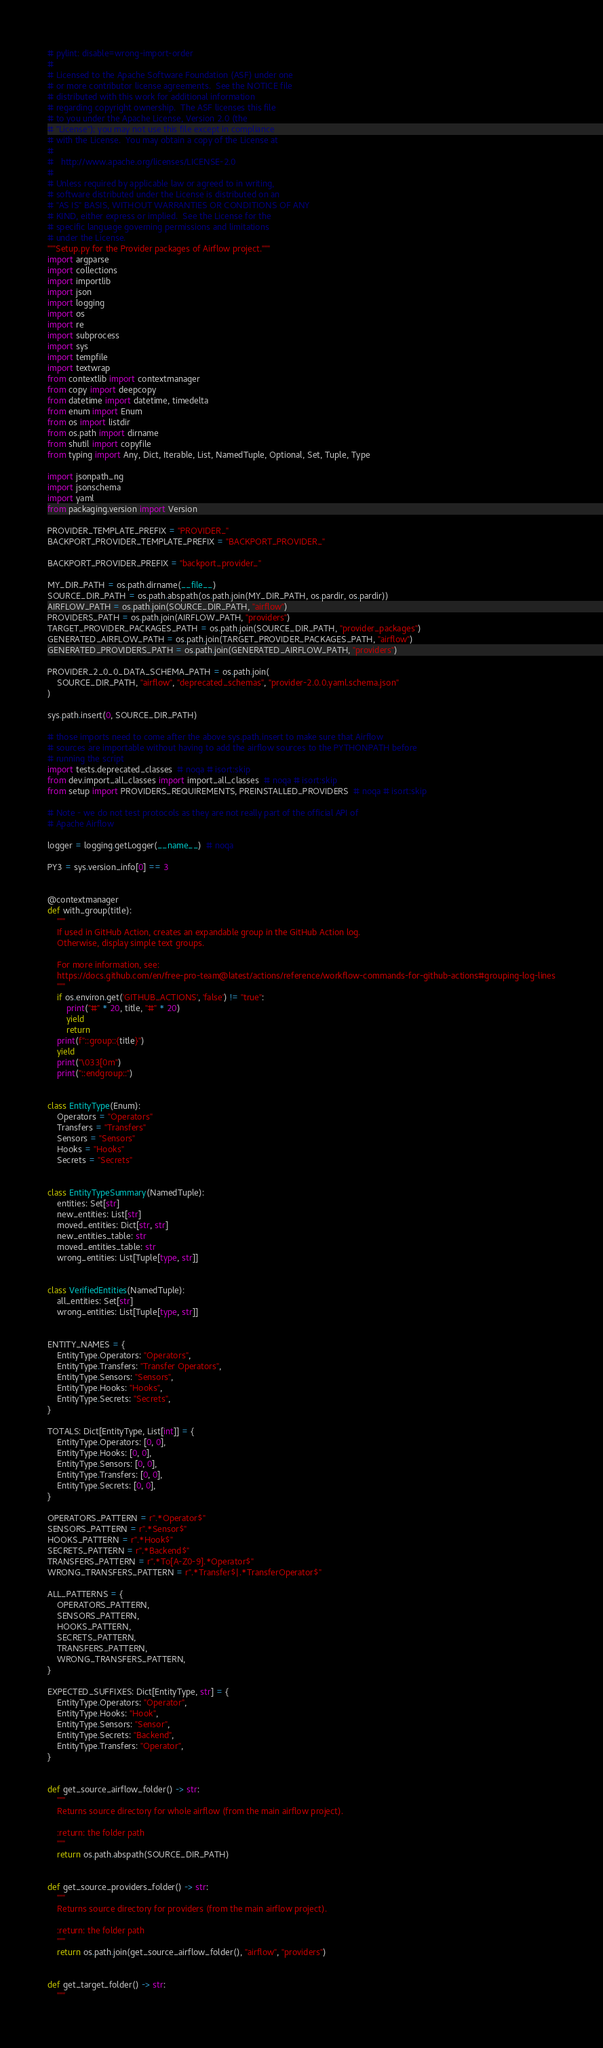<code> <loc_0><loc_0><loc_500><loc_500><_Python_># pylint: disable=wrong-import-order
#
# Licensed to the Apache Software Foundation (ASF) under one
# or more contributor license agreements.  See the NOTICE file
# distributed with this work for additional information
# regarding copyright ownership.  The ASF licenses this file
# to you under the Apache License, Version 2.0 (the
# "License"); you may not use this file except in compliance
# with the License.  You may obtain a copy of the License at
#
#   http://www.apache.org/licenses/LICENSE-2.0
#
# Unless required by applicable law or agreed to in writing,
# software distributed under the License is distributed on an
# "AS IS" BASIS, WITHOUT WARRANTIES OR CONDITIONS OF ANY
# KIND, either express or implied.  See the License for the
# specific language governing permissions and limitations
# under the License.
"""Setup.py for the Provider packages of Airflow project."""
import argparse
import collections
import importlib
import json
import logging
import os
import re
import subprocess
import sys
import tempfile
import textwrap
from contextlib import contextmanager
from copy import deepcopy
from datetime import datetime, timedelta
from enum import Enum
from os import listdir
from os.path import dirname
from shutil import copyfile
from typing import Any, Dict, Iterable, List, NamedTuple, Optional, Set, Tuple, Type

import jsonpath_ng
import jsonschema
import yaml
from packaging.version import Version

PROVIDER_TEMPLATE_PREFIX = "PROVIDER_"
BACKPORT_PROVIDER_TEMPLATE_PREFIX = "BACKPORT_PROVIDER_"

BACKPORT_PROVIDER_PREFIX = "backport_provider_"

MY_DIR_PATH = os.path.dirname(__file__)
SOURCE_DIR_PATH = os.path.abspath(os.path.join(MY_DIR_PATH, os.pardir, os.pardir))
AIRFLOW_PATH = os.path.join(SOURCE_DIR_PATH, "airflow")
PROVIDERS_PATH = os.path.join(AIRFLOW_PATH, "providers")
TARGET_PROVIDER_PACKAGES_PATH = os.path.join(SOURCE_DIR_PATH, "provider_packages")
GENERATED_AIRFLOW_PATH = os.path.join(TARGET_PROVIDER_PACKAGES_PATH, "airflow")
GENERATED_PROVIDERS_PATH = os.path.join(GENERATED_AIRFLOW_PATH, "providers")

PROVIDER_2_0_0_DATA_SCHEMA_PATH = os.path.join(
    SOURCE_DIR_PATH, "airflow", "deprecated_schemas", "provider-2.0.0.yaml.schema.json"
)

sys.path.insert(0, SOURCE_DIR_PATH)

# those imports need to come after the above sys.path.insert to make sure that Airflow
# sources are importable without having to add the airflow sources to the PYTHONPATH before
# running the script
import tests.deprecated_classes  # noqa # isort:skip
from dev.import_all_classes import import_all_classes  # noqa # isort:skip
from setup import PROVIDERS_REQUIREMENTS, PREINSTALLED_PROVIDERS  # noqa # isort:skip

# Note - we do not test protocols as they are not really part of the official API of
# Apache Airflow

logger = logging.getLogger(__name__)  # noqa

PY3 = sys.version_info[0] == 3


@contextmanager
def with_group(title):
    """
    If used in GitHub Action, creates an expandable group in the GitHub Action log.
    Otherwise, display simple text groups.

    For more information, see:
    https://docs.github.com/en/free-pro-team@latest/actions/reference/workflow-commands-for-github-actions#grouping-log-lines
    """
    if os.environ.get('GITHUB_ACTIONS', 'false') != "true":
        print("#" * 20, title, "#" * 20)
        yield
        return
    print(f"::group::{title}")
    yield
    print("\033[0m")
    print("::endgroup::")


class EntityType(Enum):
    Operators = "Operators"
    Transfers = "Transfers"
    Sensors = "Sensors"
    Hooks = "Hooks"
    Secrets = "Secrets"


class EntityTypeSummary(NamedTuple):
    entities: Set[str]
    new_entities: List[str]
    moved_entities: Dict[str, str]
    new_entities_table: str
    moved_entities_table: str
    wrong_entities: List[Tuple[type, str]]


class VerifiedEntities(NamedTuple):
    all_entities: Set[str]
    wrong_entities: List[Tuple[type, str]]


ENTITY_NAMES = {
    EntityType.Operators: "Operators",
    EntityType.Transfers: "Transfer Operators",
    EntityType.Sensors: "Sensors",
    EntityType.Hooks: "Hooks",
    EntityType.Secrets: "Secrets",
}

TOTALS: Dict[EntityType, List[int]] = {
    EntityType.Operators: [0, 0],
    EntityType.Hooks: [0, 0],
    EntityType.Sensors: [0, 0],
    EntityType.Transfers: [0, 0],
    EntityType.Secrets: [0, 0],
}

OPERATORS_PATTERN = r".*Operator$"
SENSORS_PATTERN = r".*Sensor$"
HOOKS_PATTERN = r".*Hook$"
SECRETS_PATTERN = r".*Backend$"
TRANSFERS_PATTERN = r".*To[A-Z0-9].*Operator$"
WRONG_TRANSFERS_PATTERN = r".*Transfer$|.*TransferOperator$"

ALL_PATTERNS = {
    OPERATORS_PATTERN,
    SENSORS_PATTERN,
    HOOKS_PATTERN,
    SECRETS_PATTERN,
    TRANSFERS_PATTERN,
    WRONG_TRANSFERS_PATTERN,
}

EXPECTED_SUFFIXES: Dict[EntityType, str] = {
    EntityType.Operators: "Operator",
    EntityType.Hooks: "Hook",
    EntityType.Sensors: "Sensor",
    EntityType.Secrets: "Backend",
    EntityType.Transfers: "Operator",
}


def get_source_airflow_folder() -> str:
    """
    Returns source directory for whole airflow (from the main airflow project).

    :return: the folder path
    """
    return os.path.abspath(SOURCE_DIR_PATH)


def get_source_providers_folder() -> str:
    """
    Returns source directory for providers (from the main airflow project).

    :return: the folder path
    """
    return os.path.join(get_source_airflow_folder(), "airflow", "providers")


def get_target_folder() -> str:
    """</code> 